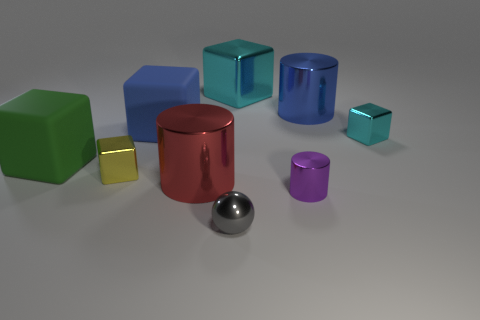Subtract all green cubes. How many cubes are left? 4 Subtract all big shiny cubes. How many cubes are left? 4 Subtract all gray cubes. Subtract all purple cylinders. How many cubes are left? 5 Subtract all cylinders. How many objects are left? 6 Add 7 green rubber things. How many green rubber things exist? 8 Subtract 1 blue cubes. How many objects are left? 8 Subtract all tiny gray metallic spheres. Subtract all red things. How many objects are left? 7 Add 4 tiny purple shiny cylinders. How many tiny purple shiny cylinders are left? 5 